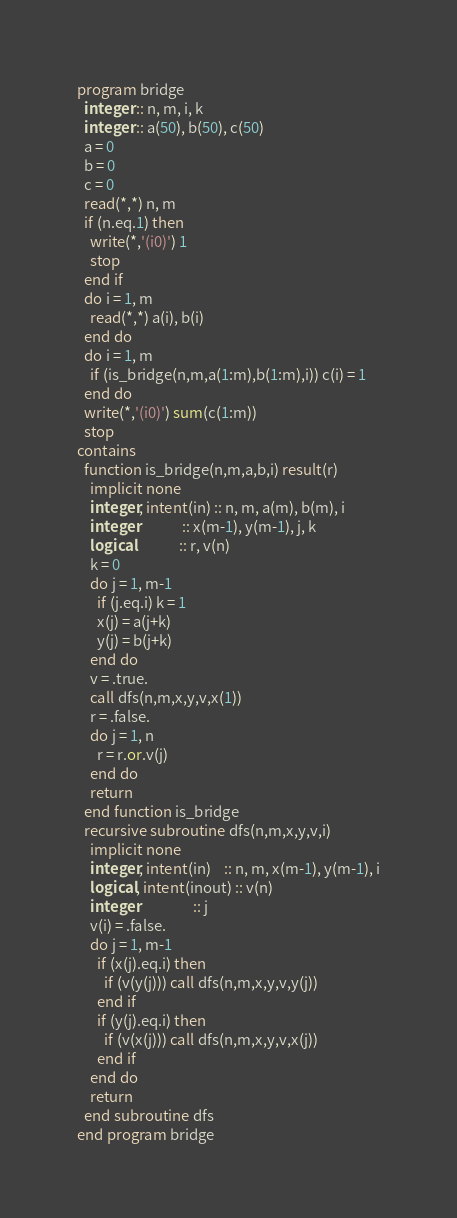Convert code to text. <code><loc_0><loc_0><loc_500><loc_500><_FORTRAN_>program bridge
  integer :: n, m, i, k
  integer :: a(50), b(50), c(50)
  a = 0
  b = 0
  c = 0
  read(*,*) n, m
  if (n.eq.1) then
    write(*,'(i0)') 1
    stop
  end if
  do i = 1, m
    read(*,*) a(i), b(i)
  end do
  do i = 1, m
    if (is_bridge(n,m,a(1:m),b(1:m),i)) c(i) = 1
  end do
  write(*,'(i0)') sum(c(1:m))
  stop
contains
  function is_bridge(n,m,a,b,i) result(r)
    implicit none
    integer, intent(in) :: n, m, a(m), b(m), i
    integer             :: x(m-1), y(m-1), j, k
    logical             :: r, v(n)
    k = 0
    do j = 1, m-1
      if (j.eq.i) k = 1
      x(j) = a(j+k)
      y(j) = b(j+k)
    end do
    v = .true.
    call dfs(n,m,x,y,v,x(1))
    r = .false.
    do j = 1, n
      r = r.or.v(j)
    end do
    return
  end function is_bridge
  recursive subroutine dfs(n,m,x,y,v,i)
    implicit none
    integer, intent(in)    :: n, m, x(m-1), y(m-1), i
    logical, intent(inout) :: v(n)
    integer                :: j
    v(i) = .false.
    do j = 1, m-1
      if (x(j).eq.i) then
        if (v(y(j))) call dfs(n,m,x,y,v,y(j))
      end if
      if (y(j).eq.i) then
        if (v(x(j))) call dfs(n,m,x,y,v,x(j))
      end if
    end do
    return
  end subroutine dfs
end program bridge</code> 